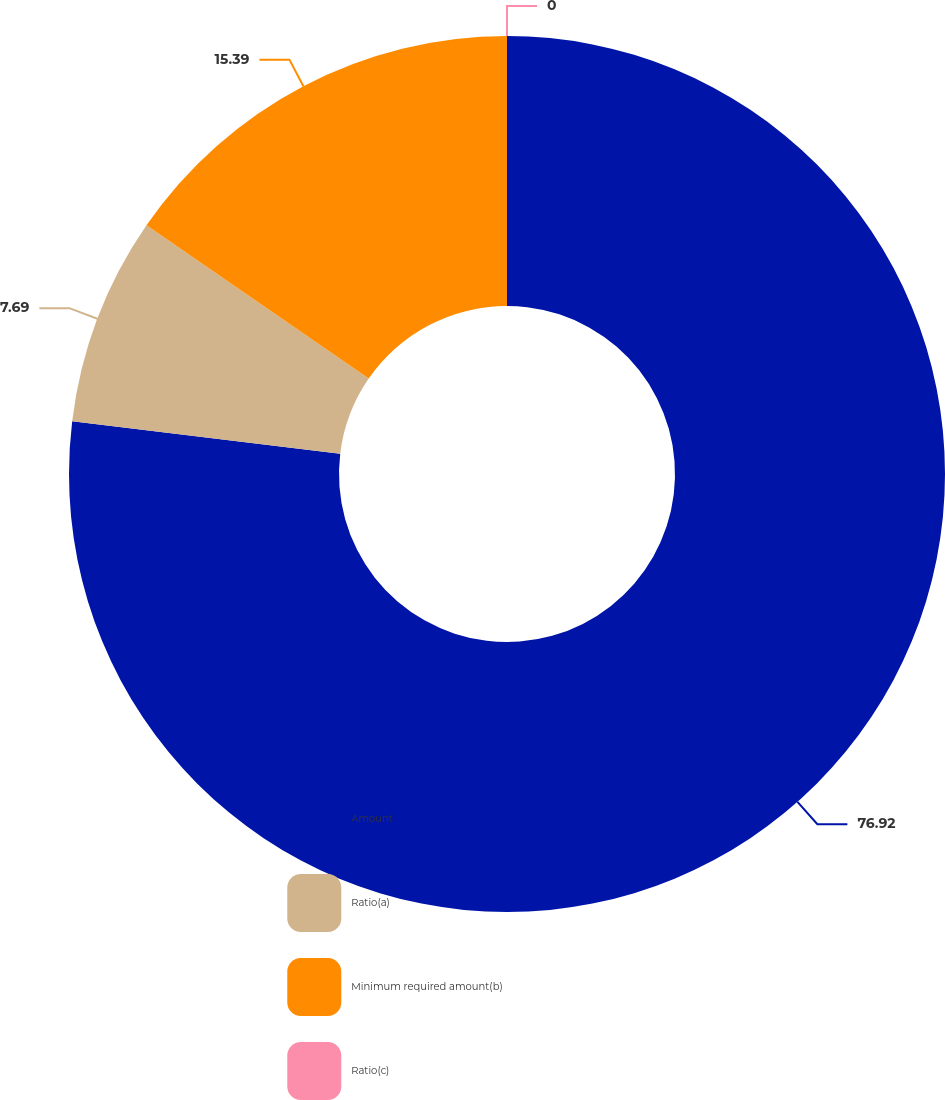Convert chart to OTSL. <chart><loc_0><loc_0><loc_500><loc_500><pie_chart><fcel>Amount<fcel>Ratio(a)<fcel>Minimum required amount(b)<fcel>Ratio(c)<nl><fcel>76.92%<fcel>7.69%<fcel>15.39%<fcel>0.0%<nl></chart> 